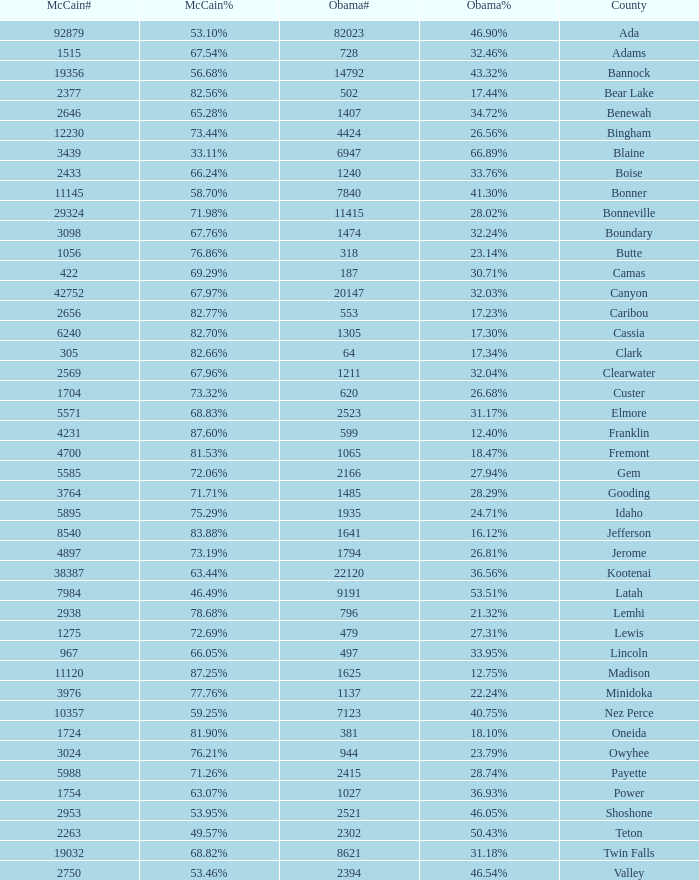What is the McCain vote percentage in Jerome county? 73.19%. 